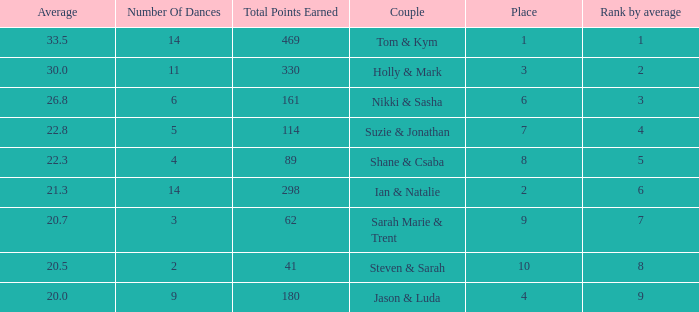What is the name of the couple if the total points earned is 161? Nikki & Sasha. 